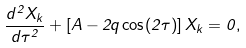Convert formula to latex. <formula><loc_0><loc_0><loc_500><loc_500>\frac { d ^ { 2 } X _ { k } } { d \tau ^ { 2 } } + \left [ A - 2 q \cos ( 2 \tau ) \right ] X _ { k } = 0 ,</formula> 